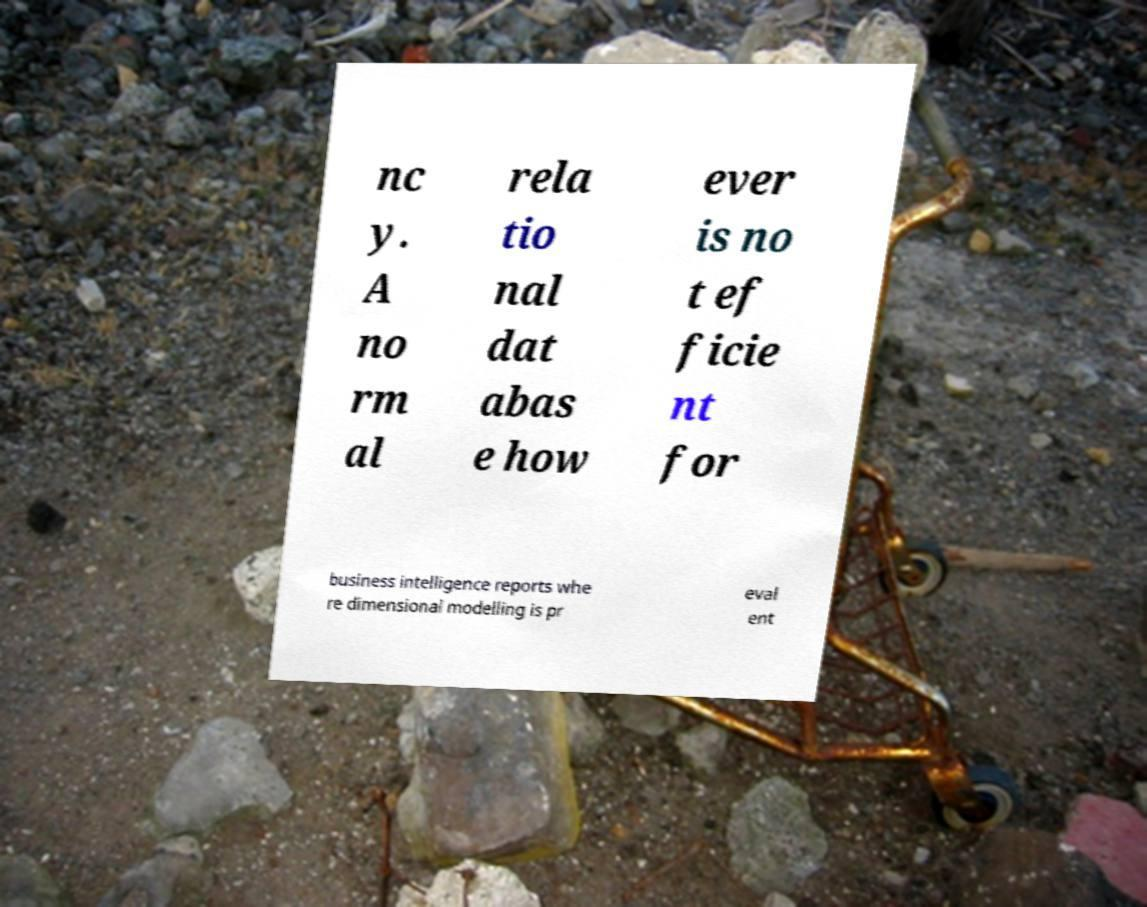Please identify and transcribe the text found in this image. nc y. A no rm al rela tio nal dat abas e how ever is no t ef ficie nt for business intelligence reports whe re dimensional modelling is pr eval ent 